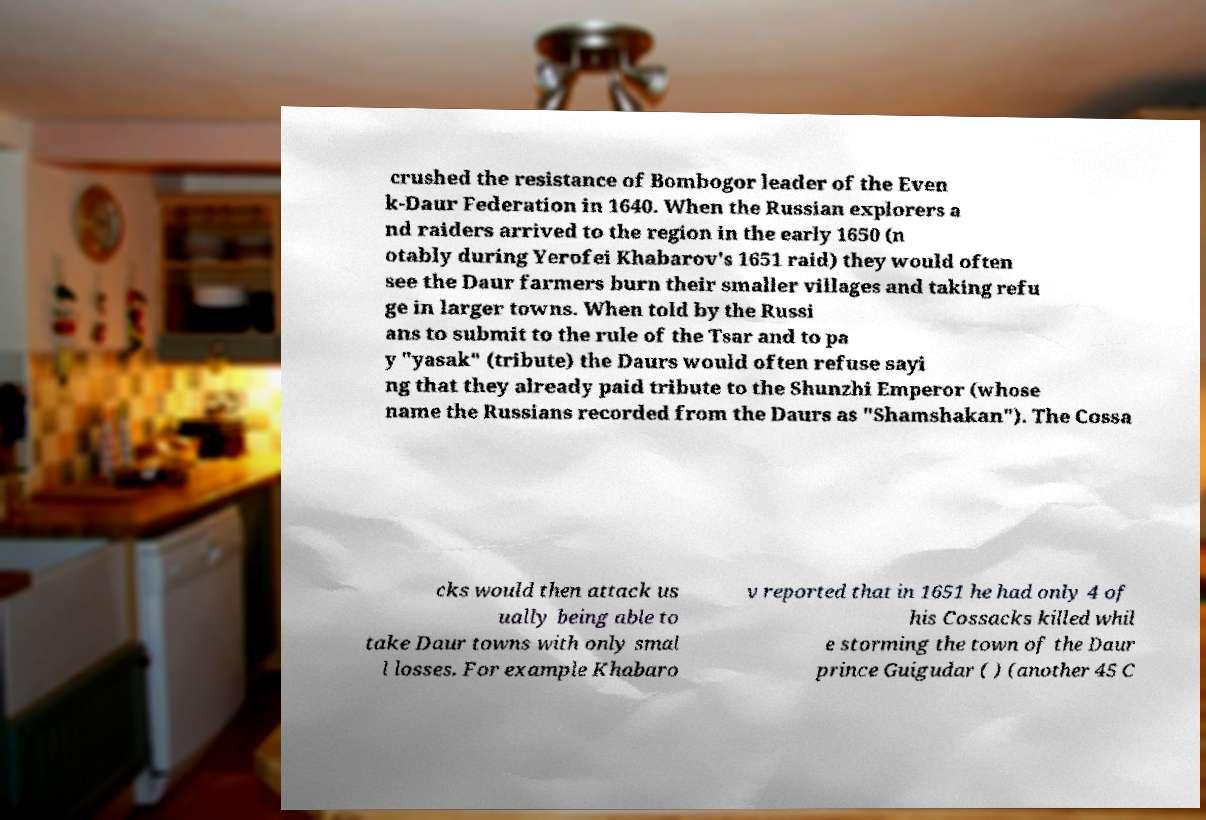There's text embedded in this image that I need extracted. Can you transcribe it verbatim? crushed the resistance of Bombogor leader of the Even k-Daur Federation in 1640. When the Russian explorers a nd raiders arrived to the region in the early 1650 (n otably during Yerofei Khabarov's 1651 raid) they would often see the Daur farmers burn their smaller villages and taking refu ge in larger towns. When told by the Russi ans to submit to the rule of the Tsar and to pa y "yasak" (tribute) the Daurs would often refuse sayi ng that they already paid tribute to the Shunzhi Emperor (whose name the Russians recorded from the Daurs as "Shamshakan"). The Cossa cks would then attack us ually being able to take Daur towns with only smal l losses. For example Khabaro v reported that in 1651 he had only 4 of his Cossacks killed whil e storming the town of the Daur prince Guigudar ( ) (another 45 C 